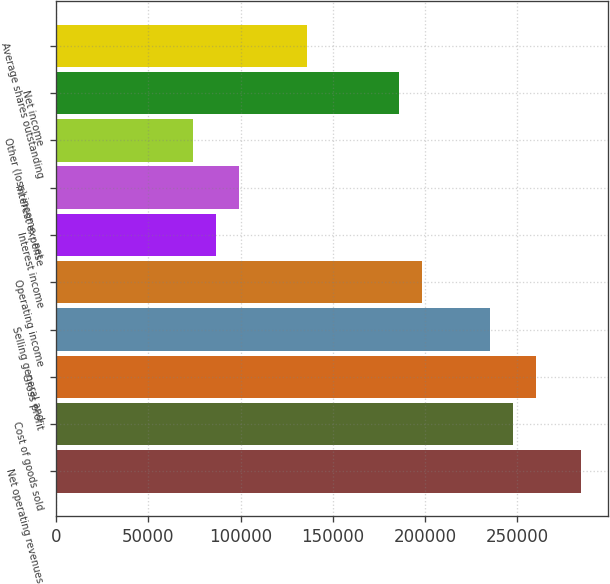Convert chart. <chart><loc_0><loc_0><loc_500><loc_500><bar_chart><fcel>Net operating revenues<fcel>Cost of goods sold<fcel>Gross profit<fcel>Selling general and<fcel>Operating income<fcel>Interest income<fcel>Interest expense<fcel>Other (loss) income - net<fcel>Net income<fcel>Average shares outstanding<nl><fcel>284987<fcel>247815<fcel>260206<fcel>235424<fcel>198252<fcel>86735.9<fcel>99126.6<fcel>74345.1<fcel>185862<fcel>136299<nl></chart> 